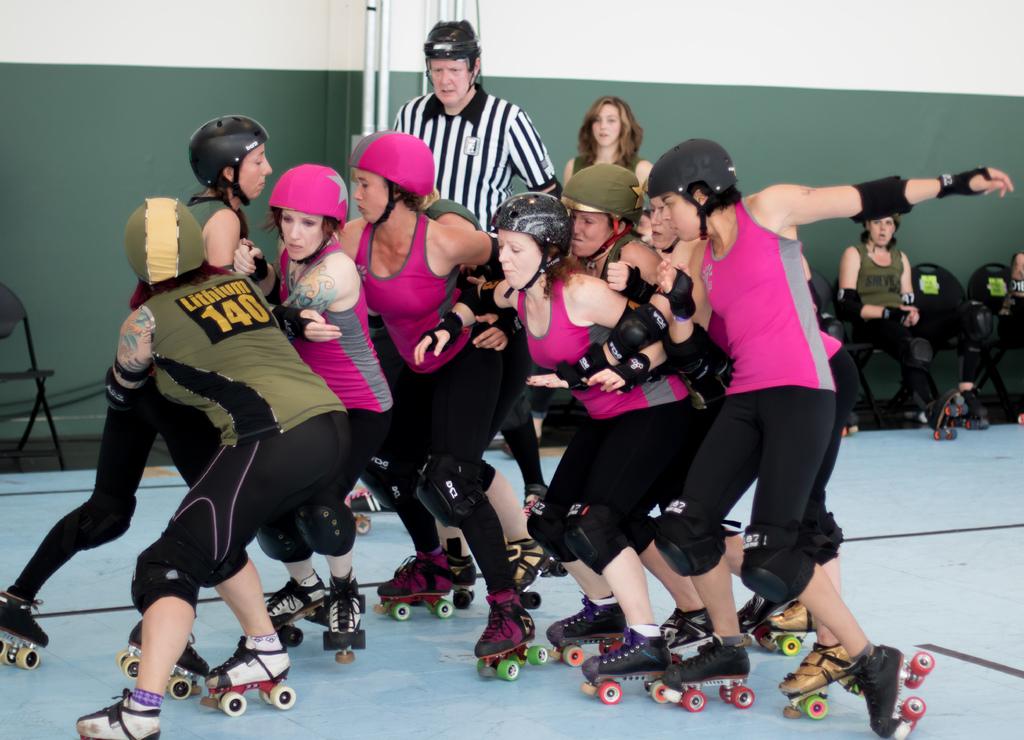What number is the green team?
Offer a very short reply. 140. What´s the name of the green team?
Offer a very short reply. Lithium. 